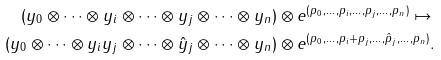Convert formula to latex. <formula><loc_0><loc_0><loc_500><loc_500>( y _ { 0 } \otimes \cdots \otimes y _ { i } \otimes \cdots \otimes y _ { j } \otimes \cdots \otimes y _ { n } ) & \otimes e ^ { ( p _ { 0 } , \dots , p _ { i } , \dots , p _ { j } , \dots , p _ { n } ) } \mapsto \\ ( y _ { 0 } \otimes \cdots \otimes y _ { i } y _ { j } \otimes \cdots \otimes \hat { y } _ { j } \otimes \cdots \otimes y _ { n } ) & \otimes e ^ { ( p _ { 0 } , \dots , p _ { i } + p _ { j } , \dots , \hat { p } _ { j } , \dots , p _ { n } ) } .</formula> 